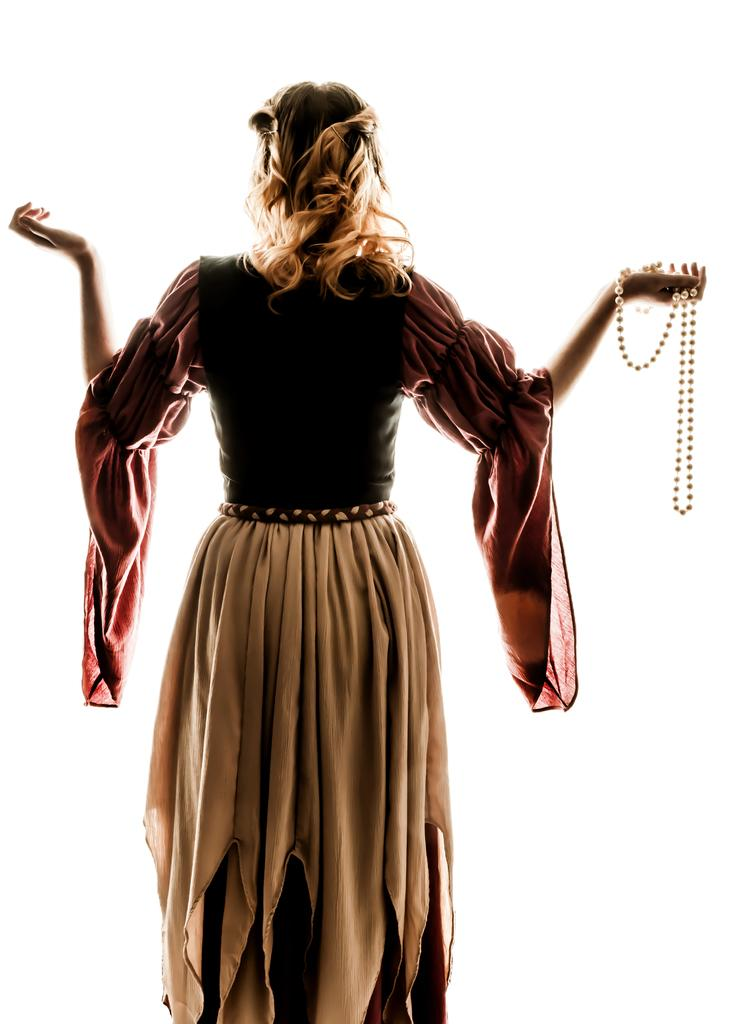Who is the main subject in the image? There is a lady in the image. What is the lady holding in the image? The lady is holding a chain. What color is the background of the image? The background of the image is white. What type of territory can be seen in the image? There is no territory visible in the image; it features a lady holding a chain against a white background. How many dinosaurs are present in the image? There are no dinosaurs present in the image. 